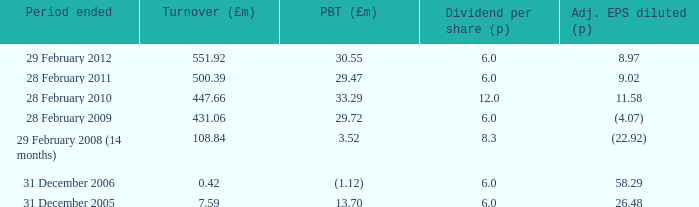What was the profit before tax when the turnover was 431.06? 29.72. 